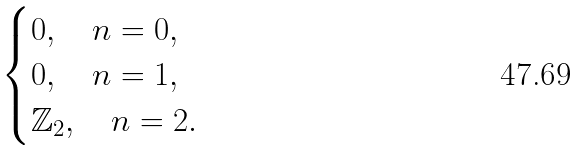<formula> <loc_0><loc_0><loc_500><loc_500>\begin{cases} 0 , \quad n = 0 , \\ 0 , \quad n = 1 , \\ \mathbb { Z } _ { 2 } , \quad n = 2 . \end{cases}</formula> 